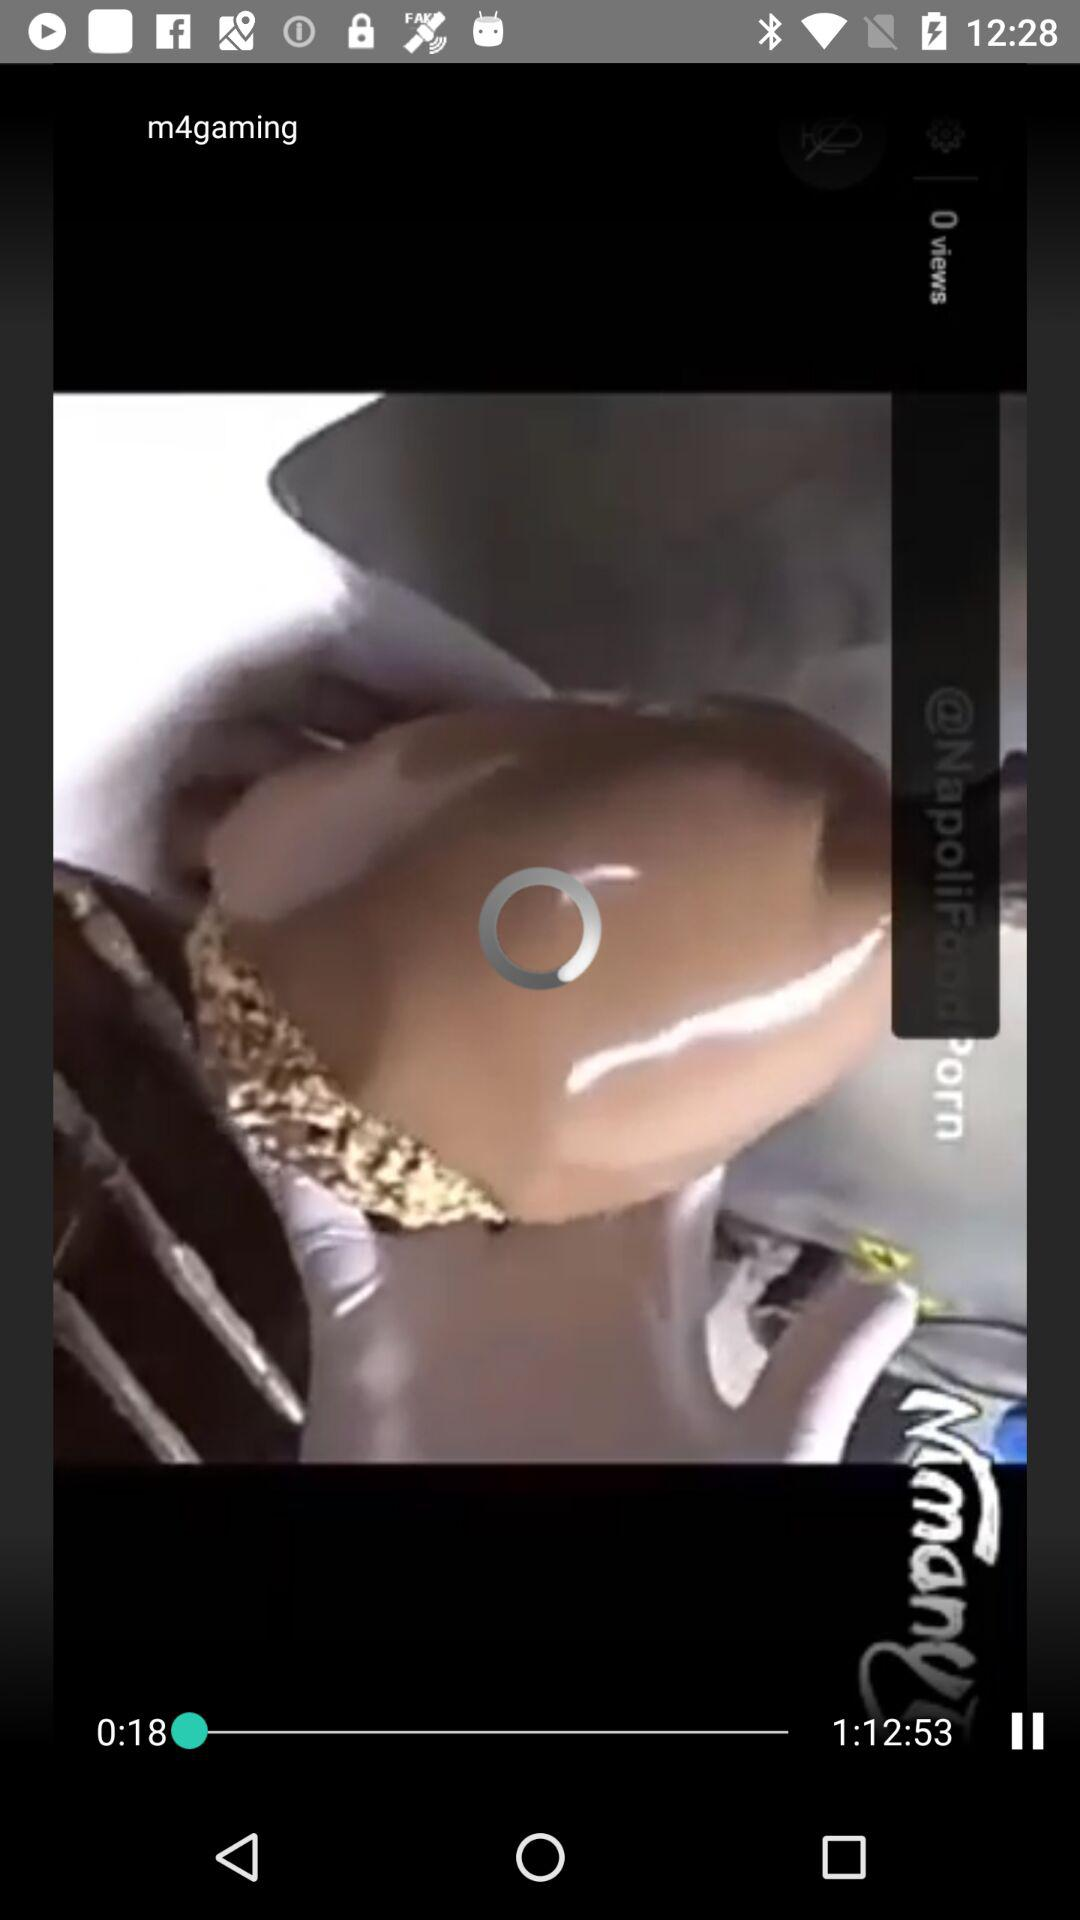What is the total duration of the video? The total duration of the video is 1 hour 12 minutes 53 seconds. 